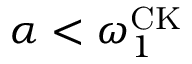<formula> <loc_0><loc_0><loc_500><loc_500>\alpha < \omega _ { 1 } ^ { C K }</formula> 